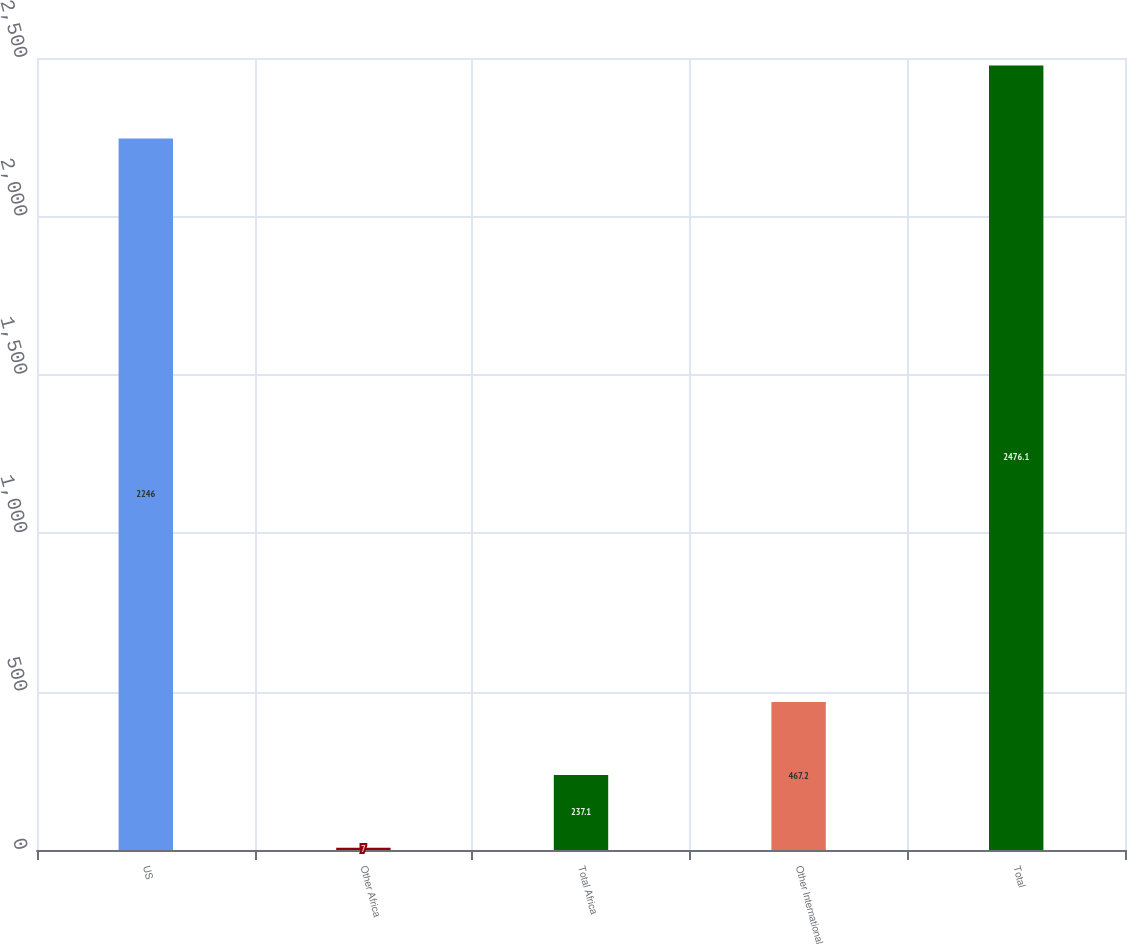<chart> <loc_0><loc_0><loc_500><loc_500><bar_chart><fcel>US<fcel>Other Africa<fcel>Total Africa<fcel>Other International<fcel>Total<nl><fcel>2246<fcel>7<fcel>237.1<fcel>467.2<fcel>2476.1<nl></chart> 